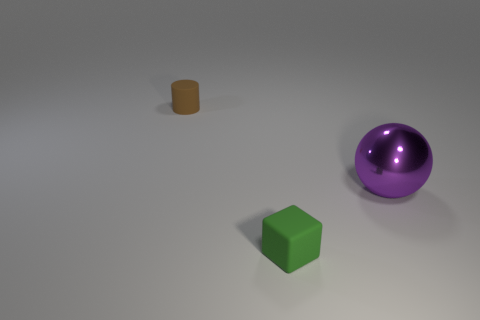Add 3 big blue blocks. How many objects exist? 6 Subtract all balls. How many objects are left? 2 Add 2 small green things. How many small green things are left? 3 Add 3 small objects. How many small objects exist? 5 Subtract 0 blue blocks. How many objects are left? 3 Subtract all matte cubes. Subtract all cylinders. How many objects are left? 1 